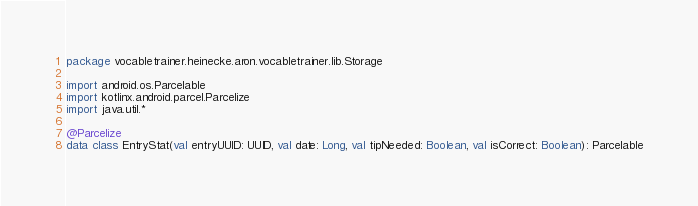Convert code to text. <code><loc_0><loc_0><loc_500><loc_500><_Kotlin_>package vocabletrainer.heinecke.aron.vocabletrainer.lib.Storage

import android.os.Parcelable
import kotlinx.android.parcel.Parcelize
import java.util.*

@Parcelize
data class EntryStat(val entryUUID: UUID, val date: Long, val tipNeeded: Boolean, val isCorrect: Boolean): Parcelable
</code> 